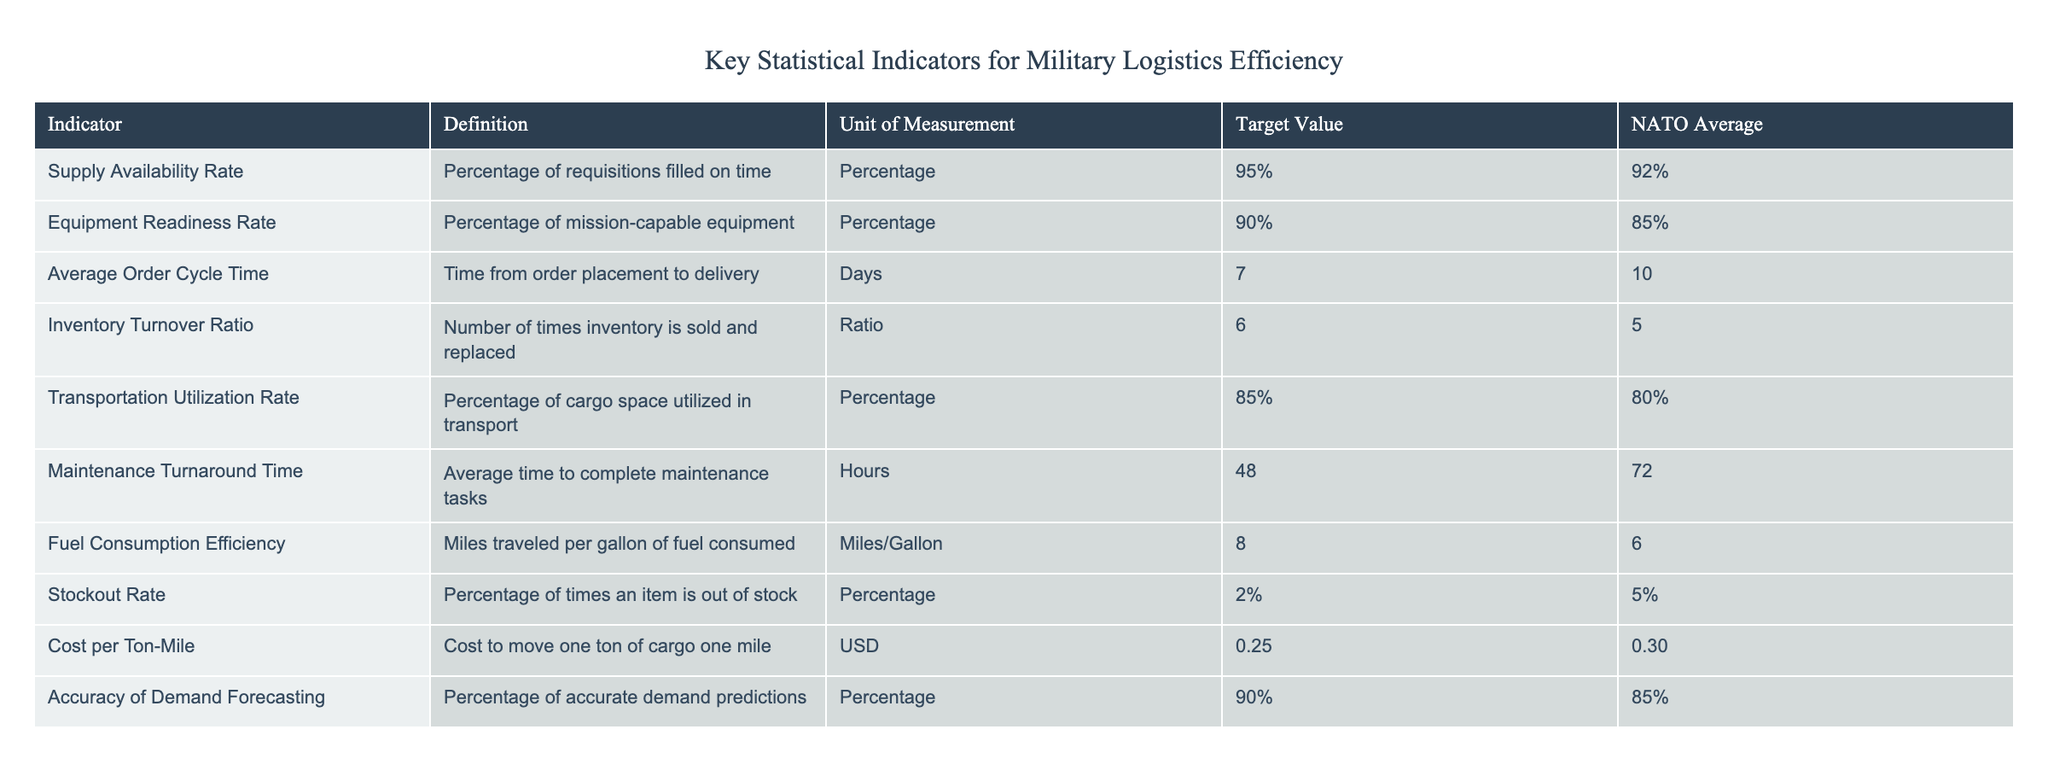What is the Target Value for Fuel Consumption Efficiency? The Target Value for Fuel Consumption Efficiency is found in the corresponding column of the table under the 'Target Value' heading for the indicator 'Fuel Consumption Efficiency,' which is 8 Miles/Gallon.
Answer: 8 Miles/Gallon What is the NATO Average for Maintenance Turnaround Time? To find the NATO Average for Maintenance Turnaround Time, we look under the 'NATO Average' column for 'Maintenance Turnaround Time,' which shows a value of 72 Hours.
Answer: 72 Hours Calculate the difference between the Target Value and NATO Average for Supply Availability Rate. The Target Value for Supply Availability Rate is 95% and the NATO Average is 92%. The difference is calculated as 95% - 92% = 3%.
Answer: 3% Is the Equipment Readiness Rate above or below 90% for NATO Average? The NATO Average for Equipment Readiness Rate is listed as 85%, which is below the 90% threshold. Thus, it is determined to be below 90%.
Answer: Below 90% What is the Average Order Cycle Time compared to the Target Value? The Average Order Cycle Time is 10 Days (NATO Average), while the Target Value is set at 7 Days. This indicates that the Average Order Cycle Time exceeds the Target Value by 3 Days.
Answer: Exceeds by 3 Days What is the Stockout Rate for NATO compared to the Target Value? The Stockout Rate in the table states the Target Value is 2% while the NATO Average is at 5%. Thus, the NATO Stockout Rate is above the Target Value.
Answer: Above the Target Value Calculate the average value between Equipment Readiness Rate and Transportation Utilization Rate for the NATO Average. The Equipment Readiness Rate (85%) and Transportation Utilization Rate (80%) are summed up: 85% + 80% = 165%, and then divided by 2 to find the average: 165% / 2 = 82.5%.
Answer: 82.5% Does the Inventory Turnover Ratio meet the Target Value? The Target Value for Inventory Turnover Ratio is set at 6, and the NATO Average is at 5. Since 5 is less than 6, it does not meet the Target Value.
Answer: No What percentage of accurate demand predictions is required according to the Target Value? The Target Value for Accuracy of Demand Forecasting is specified in the table, which states it must be 90%.
Answer: 90% 